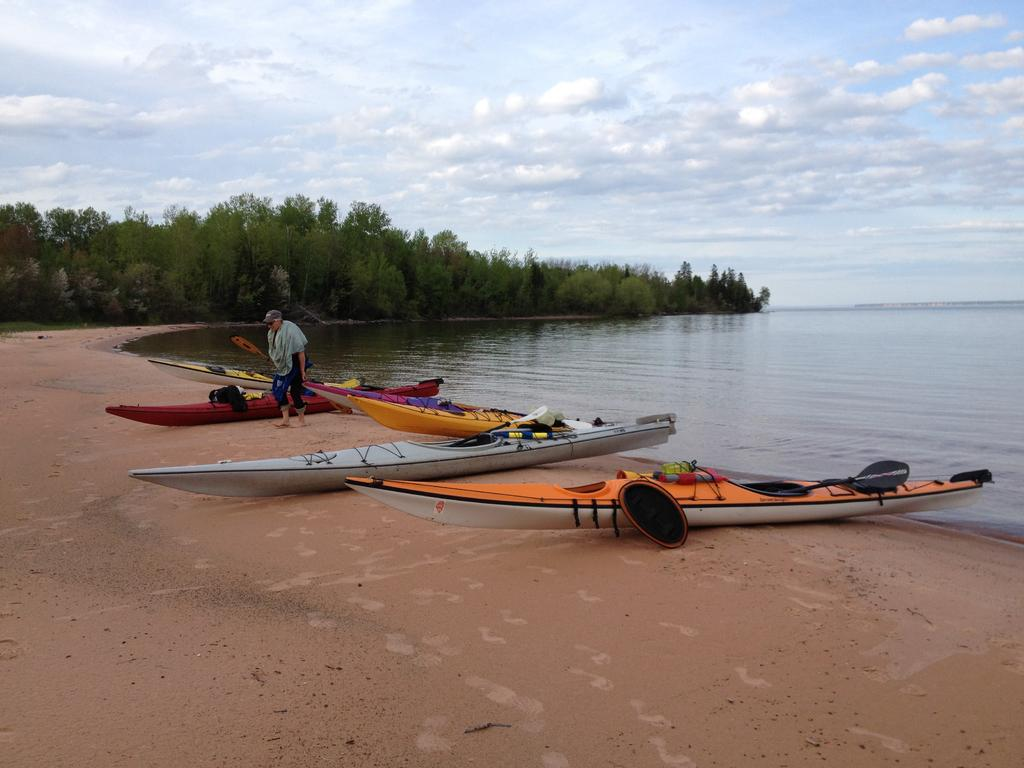What type of vehicles can be seen in the image? There are boats in the image. What type of natural environment is visible in the image? There are trees and water visible in the image. Can you describe the person in the image? There is a person in the image. What is visible in the background of the image? The sky with clouds is visible in the background of the image. What type of cake is being served on the plough in the image? There is no cake or plough present in the image. 